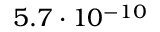<formula> <loc_0><loc_0><loc_500><loc_500>5 . 7 \cdot 1 0 ^ { - 1 0 }</formula> 